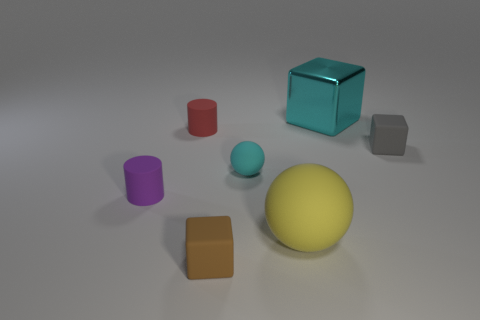There is a big cube that is the same color as the small rubber sphere; what is it made of?
Keep it short and to the point. Metal. There is another ball that is made of the same material as the large ball; what is its color?
Your answer should be compact. Cyan. What color is the cylinder right of the purple matte thing?
Ensure brevity in your answer.  Red. What number of balls have the same color as the big rubber thing?
Make the answer very short. 0. Are there fewer metallic cubes in front of the red thing than small brown rubber cubes that are left of the tiny purple thing?
Give a very brief answer. No. What number of small purple rubber cylinders are right of the red rubber cylinder?
Your answer should be very brief. 0. Are there any cyan things that have the same material as the yellow thing?
Give a very brief answer. Yes. Are there more big yellow rubber balls that are in front of the small cyan matte sphere than tiny red matte things that are right of the tiny red matte cylinder?
Give a very brief answer. Yes. What is the size of the yellow thing?
Provide a succinct answer. Large. The cyan object in front of the gray matte block has what shape?
Offer a terse response. Sphere. 